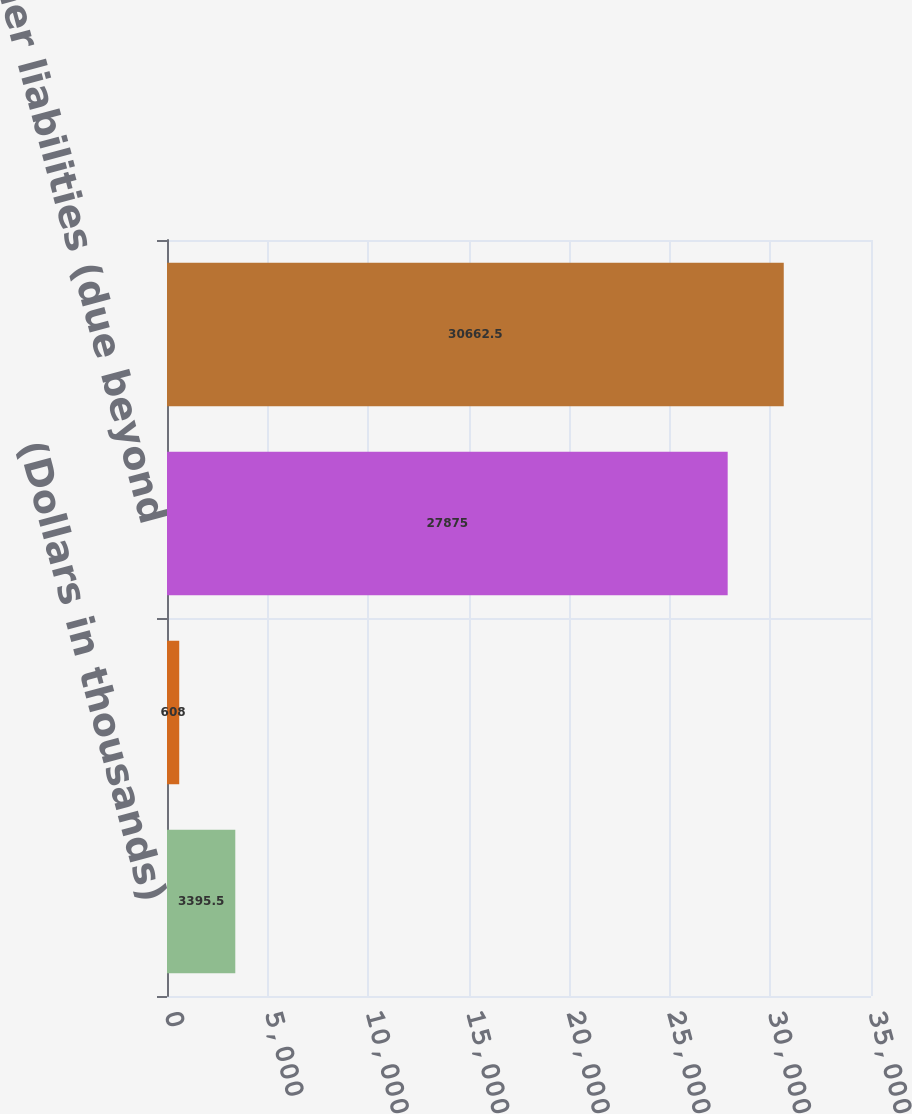<chart> <loc_0><loc_0><loc_500><loc_500><bar_chart><fcel>(Dollars in thousands)<fcel>Other liabilities (due within<fcel>Other liabilities (due beyond<fcel>Net amount recognized in the<nl><fcel>3395.5<fcel>608<fcel>27875<fcel>30662.5<nl></chart> 